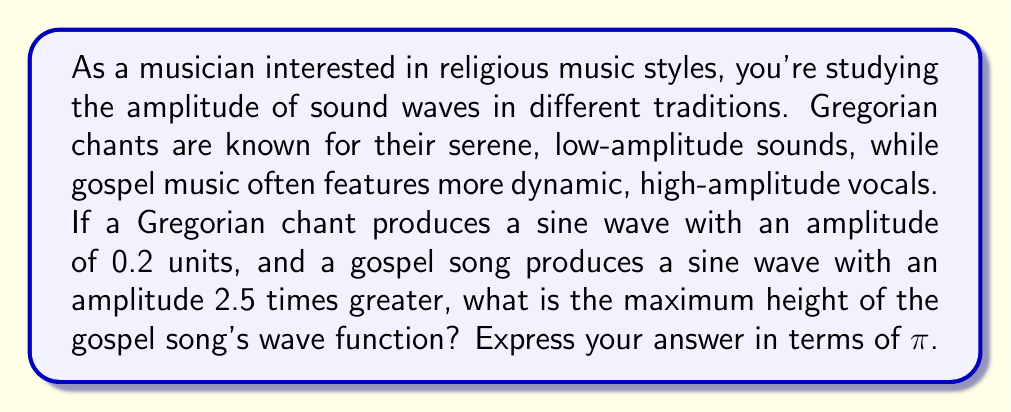Teach me how to tackle this problem. Let's approach this step-by-step:

1) First, recall the general form of a sine wave:

   $$y = A \sin(Bx + C) + D$$

   Where A is the amplitude, B is the frequency, C is the phase shift, and D is the vertical shift.

2) We're only concerned with amplitude here, so we'll focus on A.

3) For the Gregorian chant, we're given that the amplitude is 0.2 units.

4) The gospel song's amplitude is 2.5 times greater than the Gregorian chant. So we can calculate it as:

   $$A_{gospel} = 2.5 \times A_{Gregorian} = 2.5 \times 0.2 = 0.5$$

5) Now, to find the maximum height of the wave function, we need to consider that the sine function oscillates between -1 and 1.

6) The maximum height occurs when $\sin(Bx + C) = 1$, and at this point:

   $$y_{max} = A \times 1 + D$$

7) Since we're not given any vertical shift (D), we can assume it's 0.

8) Therefore, the maximum height of the gospel song's wave function is simply its amplitude:

   $$y_{max} = 0.5$$

9) The question asks for the answer in terms of π. We can express this as:

   $$y_{max} = \frac{\pi}{2\pi} \times 0.5 = \frac{\pi}{4}$$
Answer: $\frac{\pi}{4}$ 